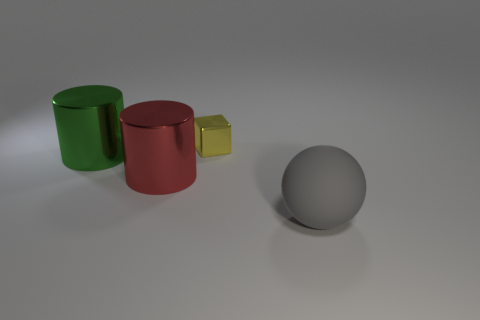Is there any other thing that has the same size as the yellow object?
Make the answer very short. No. What size is the green cylinder?
Keep it short and to the point. Large. Does the cylinder that is on the left side of the red cylinder have the same material as the block?
Provide a short and direct response. Yes. What number of large cylinders are there?
Provide a short and direct response. 2. How many objects are either large brown spheres or cylinders?
Give a very brief answer. 2. How many metal cylinders are in front of the object that is left of the big metal object that is on the right side of the large green cylinder?
Provide a succinct answer. 1. Is there anything else of the same color as the tiny shiny cube?
Your response must be concise. No. Do the big object that is on the right side of the small yellow block and the cylinder on the right side of the large green object have the same color?
Your answer should be very brief. No. Are there more large green cylinders that are in front of the sphere than spheres on the left side of the green thing?
Your response must be concise. No. What is the material of the green cylinder?
Your response must be concise. Metal. 